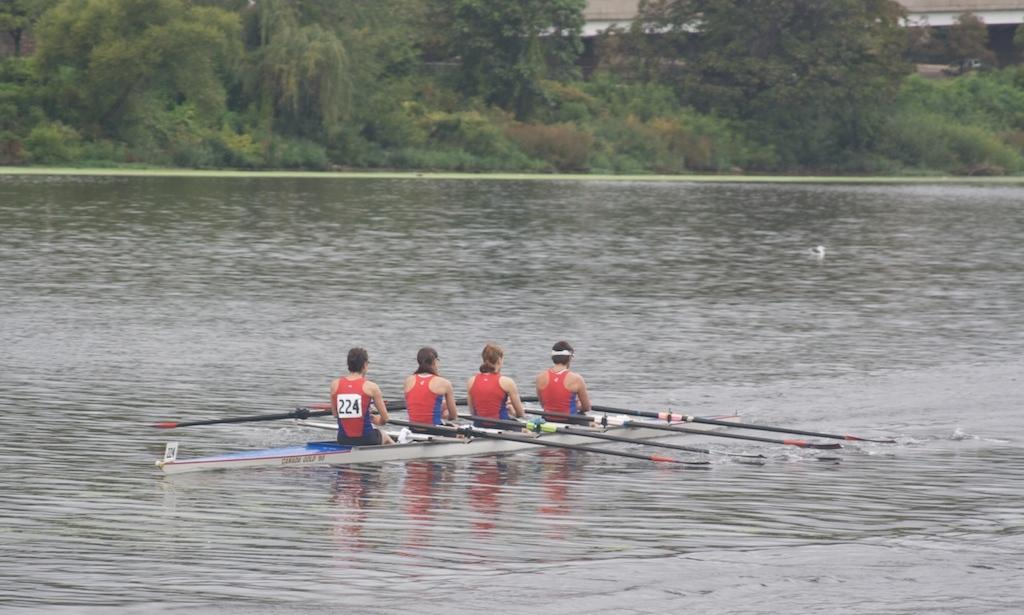What are the persons in the image doing? The persons in the image are sitting on a surf boat and rowing it. Where is the surf boat located? The surf boat is on the water. What can be seen in the background of the image? There are trees in the background of the image. What type of support can be seen holding up the wine in the image? There is no wine or support present in the image; it features persons rowing a surf boat on the water with trees in the background. 